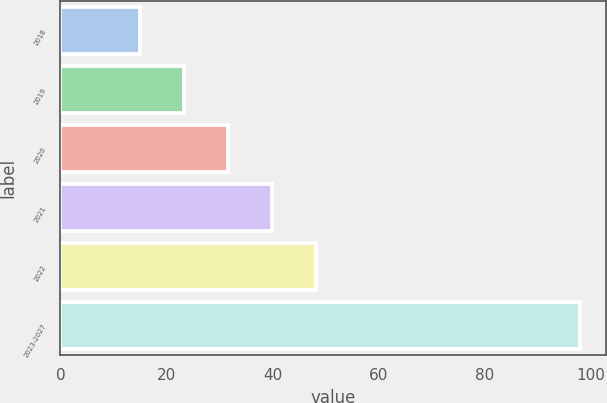Convert chart. <chart><loc_0><loc_0><loc_500><loc_500><bar_chart><fcel>2018<fcel>2019<fcel>2020<fcel>2021<fcel>2022<fcel>2023-2027<nl><fcel>15<fcel>23.3<fcel>31.6<fcel>39.9<fcel>48.2<fcel>98<nl></chart> 